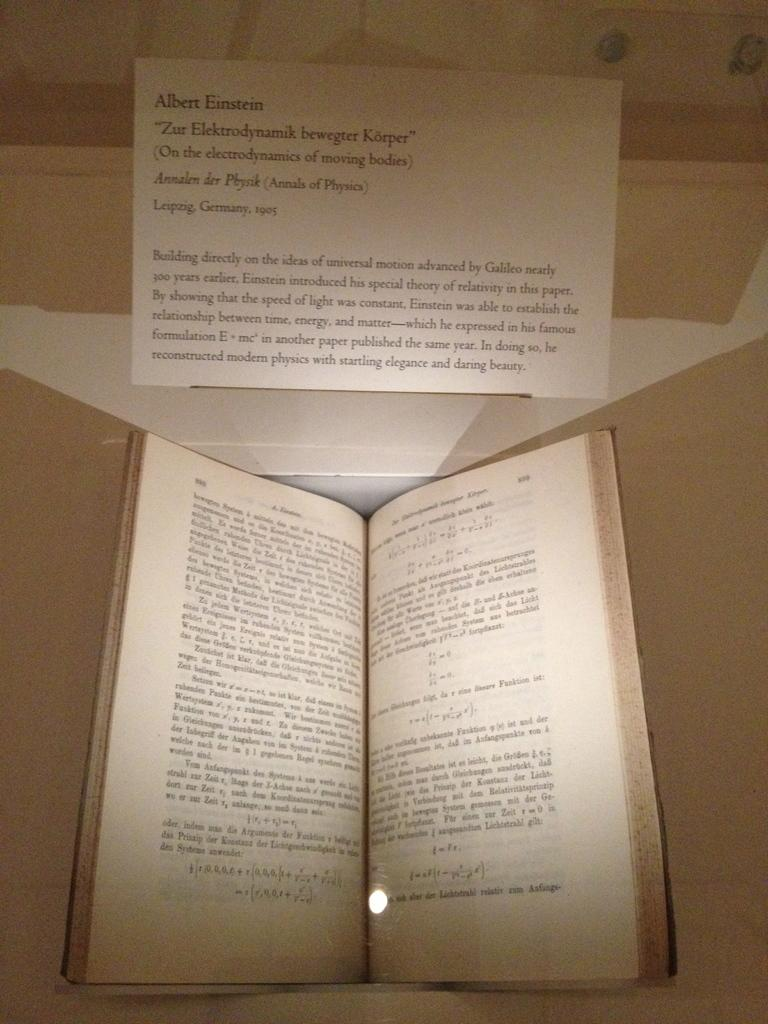<image>
Provide a brief description of the given image. a card above an open book that says 'albert einstein' on it 